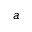Convert formula to latex. <formula><loc_0><loc_0><loc_500><loc_500>a</formula> 